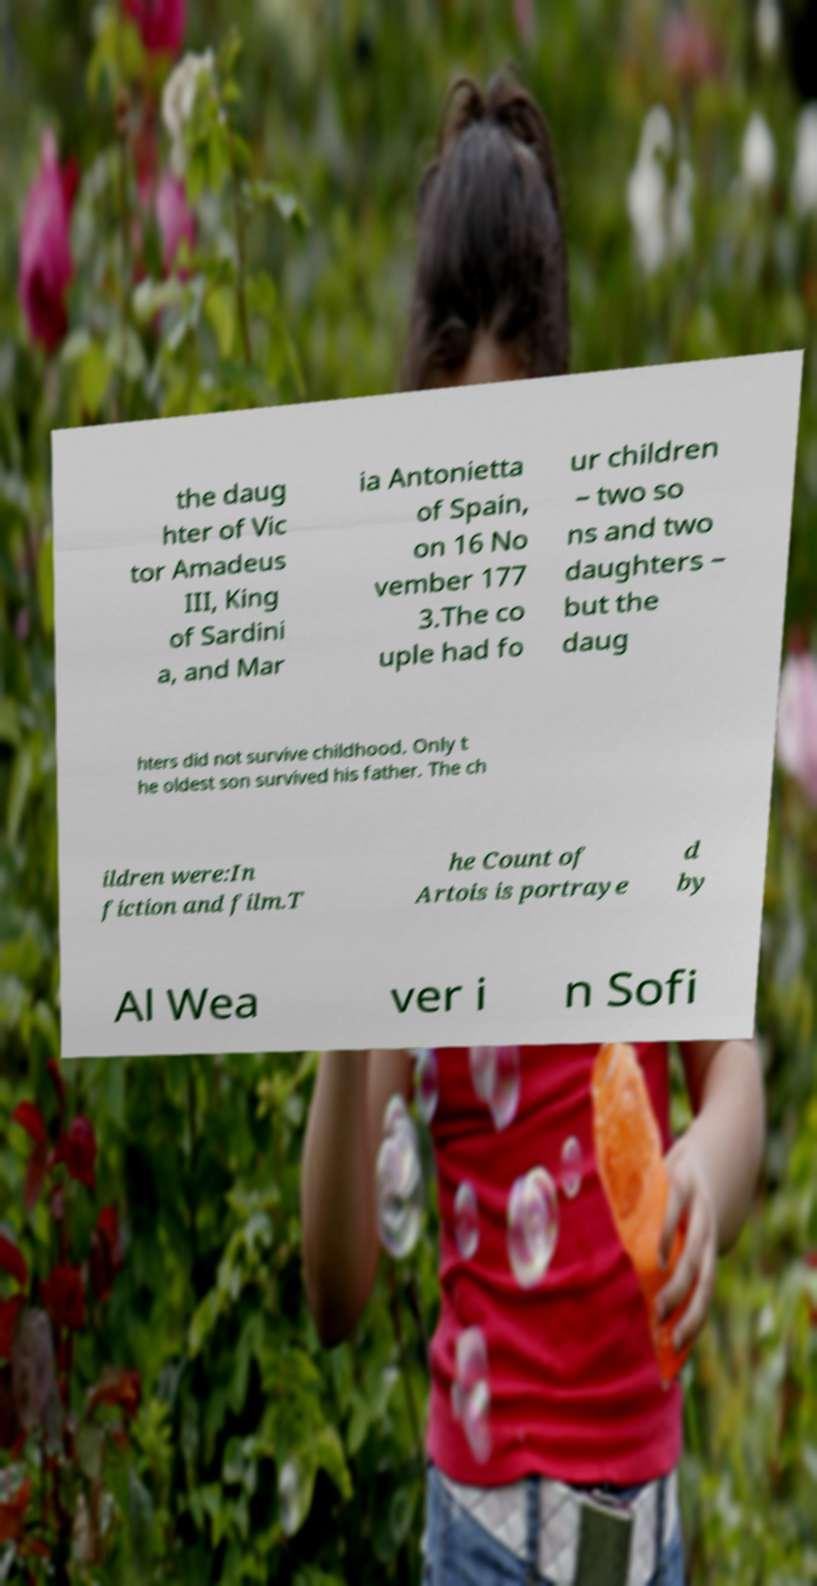There's text embedded in this image that I need extracted. Can you transcribe it verbatim? the daug hter of Vic tor Amadeus III, King of Sardini a, and Mar ia Antonietta of Spain, on 16 No vember 177 3.The co uple had fo ur children – two so ns and two daughters – but the daug hters did not survive childhood. Only t he oldest son survived his father. The ch ildren were:In fiction and film.T he Count of Artois is portraye d by Al Wea ver i n Sofi 